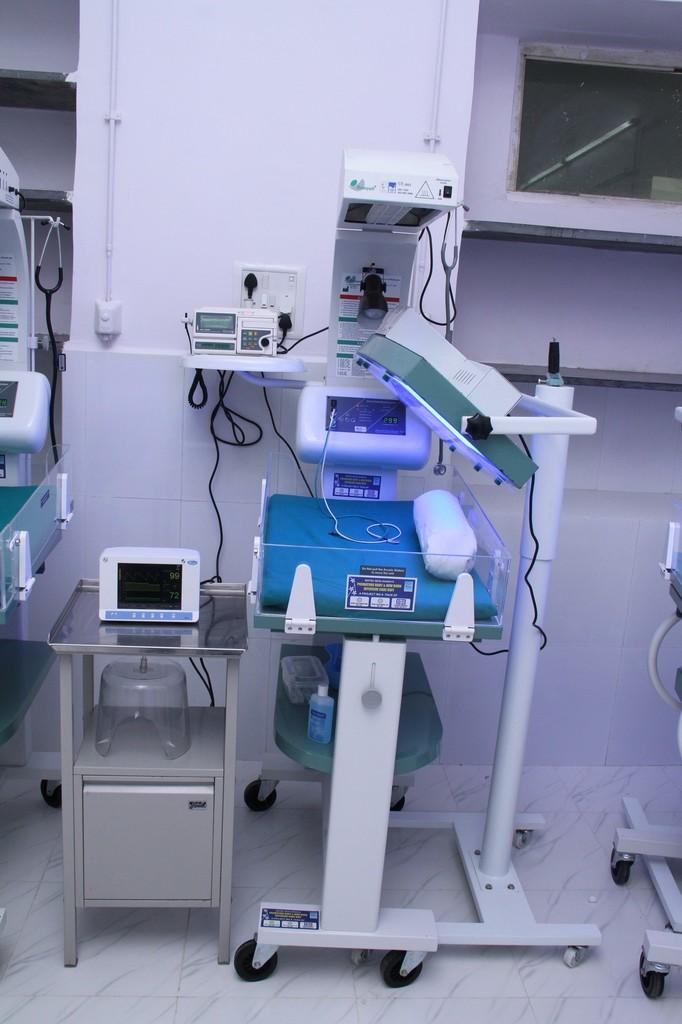What type of objects can be seen in the image? There are machines in the image. Where is the steel table located in the image? The steel table is on the left side of the image. What can be found in the top right corner of the image? There are shelves and a window in the top right corner of the image. Can you see any dirt on the machines in the image? There is no mention of dirt in the image, so we cannot determine if there is any dirt on the machines. 